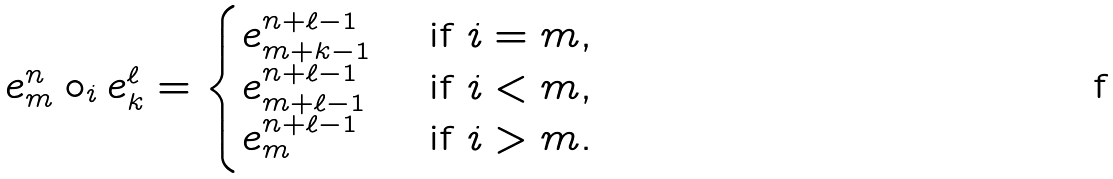<formula> <loc_0><loc_0><loc_500><loc_500>e ^ { n } _ { m } \circ _ { i } e ^ { \ell } _ { k } = \begin{cases} \strut e ^ { n + \ell - 1 } _ { m + k - 1 } & \text { if } i = m , \\ \strut e ^ { n + \ell - 1 } _ { m + \ell - 1 } & \text { if } i < m , \\ \strut e ^ { n + \ell - 1 } _ { m } & \text { if } i > m . \end{cases}</formula> 